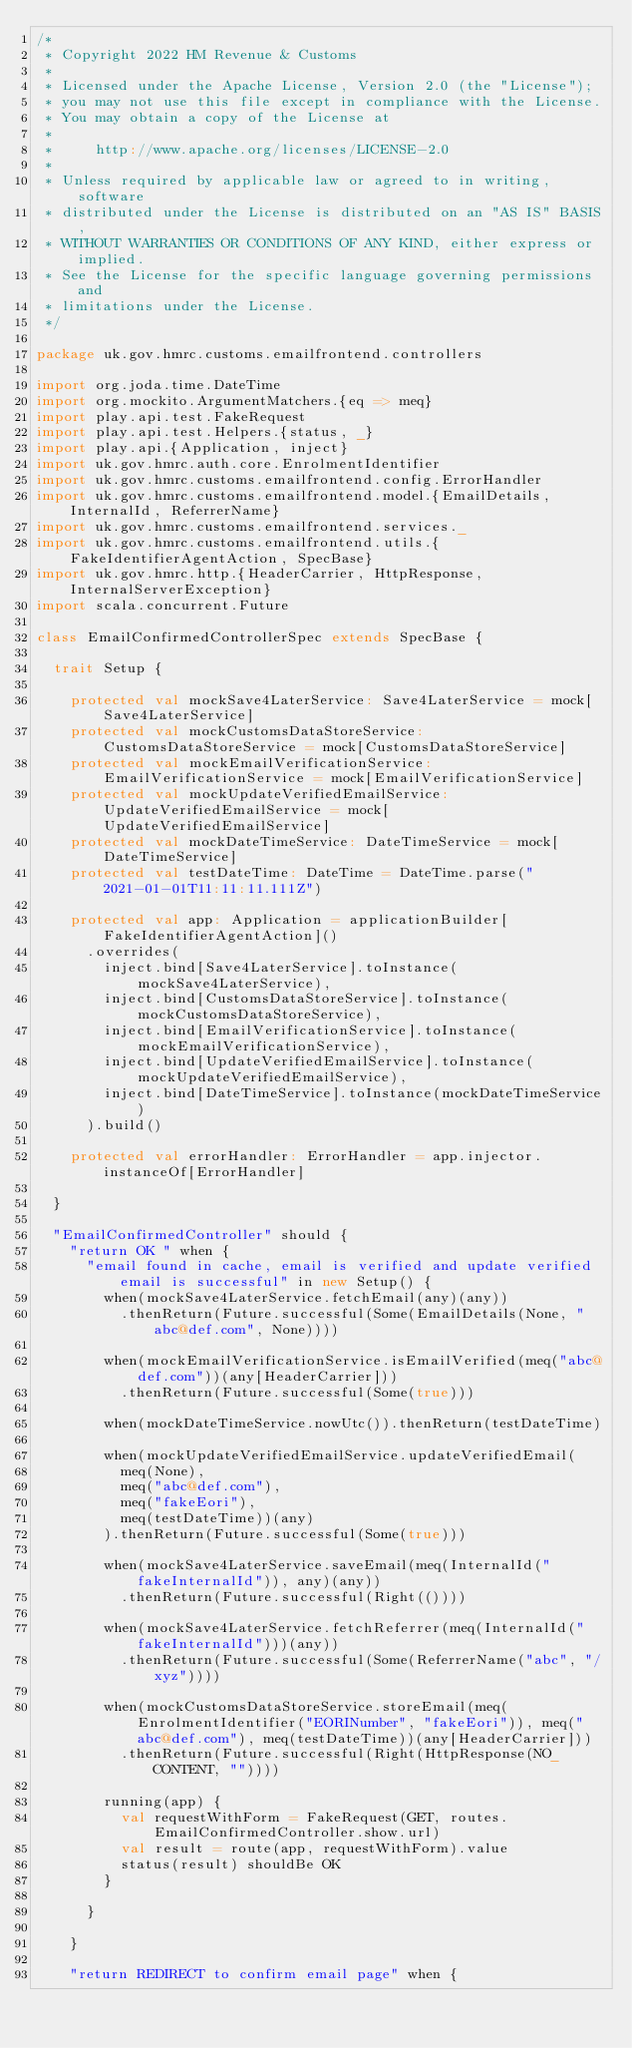<code> <loc_0><loc_0><loc_500><loc_500><_Scala_>/*
 * Copyright 2022 HM Revenue & Customs
 *
 * Licensed under the Apache License, Version 2.0 (the "License");
 * you may not use this file except in compliance with the License.
 * You may obtain a copy of the License at
 *
 *     http://www.apache.org/licenses/LICENSE-2.0
 *
 * Unless required by applicable law or agreed to in writing, software
 * distributed under the License is distributed on an "AS IS" BASIS,
 * WITHOUT WARRANTIES OR CONDITIONS OF ANY KIND, either express or implied.
 * See the License for the specific language governing permissions and
 * limitations under the License.
 */

package uk.gov.hmrc.customs.emailfrontend.controllers

import org.joda.time.DateTime
import org.mockito.ArgumentMatchers.{eq => meq}
import play.api.test.FakeRequest
import play.api.test.Helpers.{status, _}
import play.api.{Application, inject}
import uk.gov.hmrc.auth.core.EnrolmentIdentifier
import uk.gov.hmrc.customs.emailfrontend.config.ErrorHandler
import uk.gov.hmrc.customs.emailfrontend.model.{EmailDetails, InternalId, ReferrerName}
import uk.gov.hmrc.customs.emailfrontend.services._
import uk.gov.hmrc.customs.emailfrontend.utils.{FakeIdentifierAgentAction, SpecBase}
import uk.gov.hmrc.http.{HeaderCarrier, HttpResponse, InternalServerException}
import scala.concurrent.Future

class EmailConfirmedControllerSpec extends SpecBase {

  trait Setup {

    protected val mockSave4LaterService: Save4LaterService = mock[Save4LaterService]
    protected val mockCustomsDataStoreService: CustomsDataStoreService = mock[CustomsDataStoreService]
    protected val mockEmailVerificationService: EmailVerificationService = mock[EmailVerificationService]
    protected val mockUpdateVerifiedEmailService: UpdateVerifiedEmailService = mock[UpdateVerifiedEmailService]
    protected val mockDateTimeService: DateTimeService = mock[DateTimeService]
    protected val testDateTime: DateTime = DateTime.parse("2021-01-01T11:11:11.111Z")

    protected val app: Application = applicationBuilder[FakeIdentifierAgentAction]()
      .overrides(
        inject.bind[Save4LaterService].toInstance(mockSave4LaterService),
        inject.bind[CustomsDataStoreService].toInstance(mockCustomsDataStoreService),
        inject.bind[EmailVerificationService].toInstance(mockEmailVerificationService),
        inject.bind[UpdateVerifiedEmailService].toInstance(mockUpdateVerifiedEmailService),
        inject.bind[DateTimeService].toInstance(mockDateTimeService)
      ).build()

    protected val errorHandler: ErrorHandler = app.injector.instanceOf[ErrorHandler]

  }

  "EmailConfirmedController" should {
    "return OK " when {
      "email found in cache, email is verified and update verified email is successful" in new Setup() {
        when(mockSave4LaterService.fetchEmail(any)(any))
          .thenReturn(Future.successful(Some(EmailDetails(None, "abc@def.com", None))))

        when(mockEmailVerificationService.isEmailVerified(meq("abc@def.com"))(any[HeaderCarrier]))
          .thenReturn(Future.successful(Some(true)))

        when(mockDateTimeService.nowUtc()).thenReturn(testDateTime)

        when(mockUpdateVerifiedEmailService.updateVerifiedEmail(
          meq(None),
          meq("abc@def.com"),
          meq("fakeEori"),
          meq(testDateTime))(any)
        ).thenReturn(Future.successful(Some(true)))

        when(mockSave4LaterService.saveEmail(meq(InternalId("fakeInternalId")), any)(any))
          .thenReturn(Future.successful(Right(())))

        when(mockSave4LaterService.fetchReferrer(meq(InternalId("fakeInternalId")))(any))
          .thenReturn(Future.successful(Some(ReferrerName("abc", "/xyz"))))

        when(mockCustomsDataStoreService.storeEmail(meq(EnrolmentIdentifier("EORINumber", "fakeEori")), meq("abc@def.com"), meq(testDateTime))(any[HeaderCarrier]))
          .thenReturn(Future.successful(Right(HttpResponse(NO_CONTENT, ""))))

        running(app) {
          val requestWithForm = FakeRequest(GET, routes.EmailConfirmedController.show.url)
          val result = route(app, requestWithForm).value
          status(result) shouldBe OK
        }

      }

    }

    "return REDIRECT to confirm email page" when {</code> 